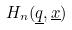Convert formula to latex. <formula><loc_0><loc_0><loc_500><loc_500>H _ { n } ( \underline { q } , \underline { x } )</formula> 